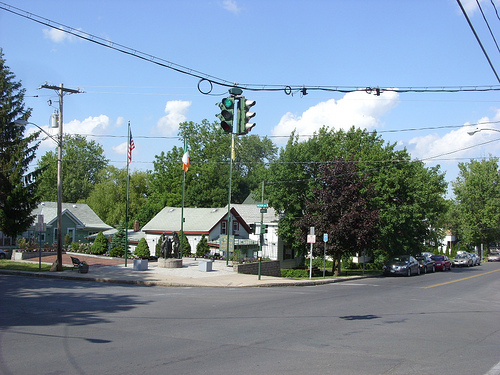How many black horses are there in the image? There are no black horses in the image. The photo shows a tranquil street scene with a war memorial, lush green trees, and clear skies, but no horses or other animals are visible. 